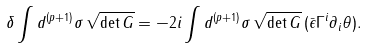<formula> <loc_0><loc_0><loc_500><loc_500>\delta \int d ^ { ( p + 1 ) } \sigma \, \sqrt { \det G } = - 2 i \int d ^ { ( p + 1 ) } \sigma \, \sqrt { \det G } \, ( \bar { \epsilon } \Gamma ^ { i } \partial _ { i } \theta ) .</formula> 